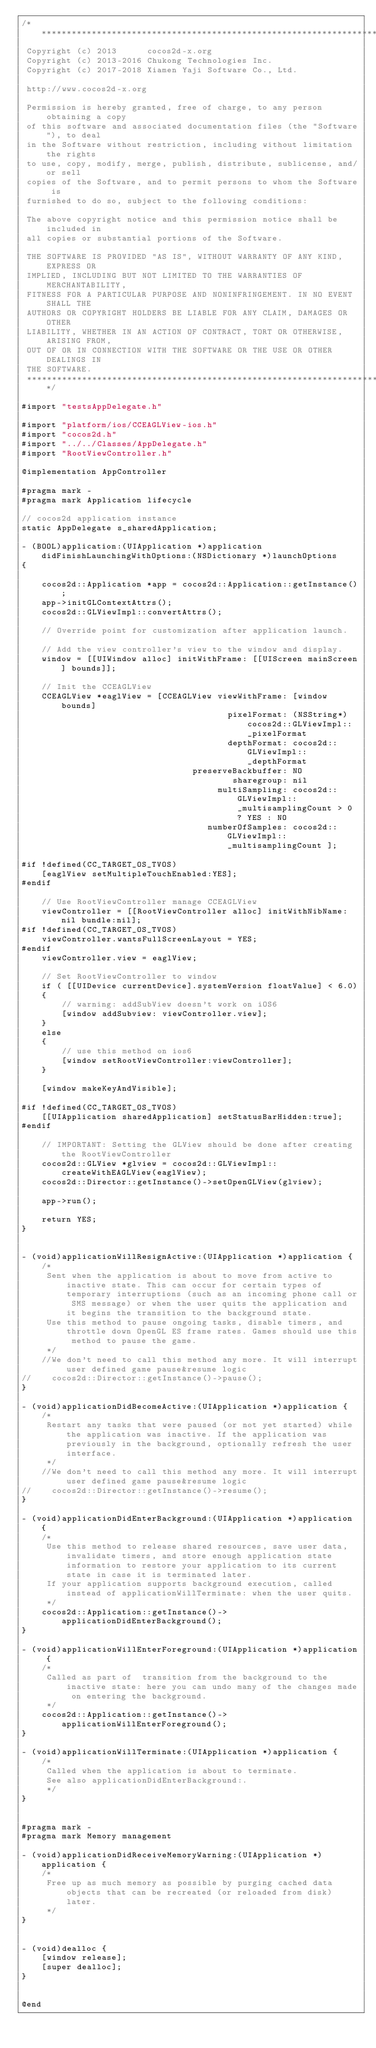Convert code to text. <code><loc_0><loc_0><loc_500><loc_500><_ObjectiveC_>/****************************************************************************
 Copyright (c) 2013      cocos2d-x.org
 Copyright (c) 2013-2016 Chukong Technologies Inc.
 Copyright (c) 2017-2018 Xiamen Yaji Software Co., Ltd.

 http://www.cocos2d-x.org

 Permission is hereby granted, free of charge, to any person obtaining a copy
 of this software and associated documentation files (the "Software"), to deal
 in the Software without restriction, including without limitation the rights
 to use, copy, modify, merge, publish, distribute, sublicense, and/or sell
 copies of the Software, and to permit persons to whom the Software is
 furnished to do so, subject to the following conditions:

 The above copyright notice and this permission notice shall be included in
 all copies or substantial portions of the Software.

 THE SOFTWARE IS PROVIDED "AS IS", WITHOUT WARRANTY OF ANY KIND, EXPRESS OR
 IMPLIED, INCLUDING BUT NOT LIMITED TO THE WARRANTIES OF MERCHANTABILITY,
 FITNESS FOR A PARTICULAR PURPOSE AND NONINFRINGEMENT. IN NO EVENT SHALL THE
 AUTHORS OR COPYRIGHT HOLDERS BE LIABLE FOR ANY CLAIM, DAMAGES OR OTHER
 LIABILITY, WHETHER IN AN ACTION OF CONTRACT, TORT OR OTHERWISE, ARISING FROM,
 OUT OF OR IN CONNECTION WITH THE SOFTWARE OR THE USE OR OTHER DEALINGS IN
 THE SOFTWARE.
 ****************************************************************************/

#import "testsAppDelegate.h"

#import "platform/ios/CCEAGLView-ios.h"
#import "cocos2d.h"
#import "../../Classes/AppDelegate.h"
#import "RootViewController.h"

@implementation AppController

#pragma mark -
#pragma mark Application lifecycle

// cocos2d application instance
static AppDelegate s_sharedApplication;

- (BOOL)application:(UIApplication *)application didFinishLaunchingWithOptions:(NSDictionary *)launchOptions
{

    cocos2d::Application *app = cocos2d::Application::getInstance();
    app->initGLContextAttrs();
    cocos2d::GLViewImpl::convertAttrs();

    // Override point for customization after application launch.

    // Add the view controller's view to the window and display.
    window = [[UIWindow alloc] initWithFrame: [[UIScreen mainScreen] bounds]];

    // Init the CCEAGLView
    CCEAGLView *eaglView = [CCEAGLView viewWithFrame: [window bounds]
                                         pixelFormat: (NSString*)cocos2d::GLViewImpl::_pixelFormat
                                         depthFormat: cocos2d::GLViewImpl::_depthFormat
                                  preserveBackbuffer: NO
                                          sharegroup: nil
                                       multiSampling: cocos2d::GLViewImpl::_multisamplingCount > 0 ? YES : NO
                                     numberOfSamples: cocos2d::GLViewImpl::_multisamplingCount ];

#if !defined(CC_TARGET_OS_TVOS)
    [eaglView setMultipleTouchEnabled:YES];
#endif

    // Use RootViewController manage CCEAGLView
    viewController = [[RootViewController alloc] initWithNibName:nil bundle:nil];
#if !defined(CC_TARGET_OS_TVOS)
    viewController.wantsFullScreenLayout = YES;
#endif
    viewController.view = eaglView;

    // Set RootViewController to window
    if ( [[UIDevice currentDevice].systemVersion floatValue] < 6.0)
    {
        // warning: addSubView doesn't work on iOS6
        [window addSubview: viewController.view];
    }
    else
    {
        // use this method on ios6
        [window setRootViewController:viewController];
    }
    
    [window makeKeyAndVisible];

#if !defined(CC_TARGET_OS_TVOS)
    [[UIApplication sharedApplication] setStatusBarHidden:true];
#endif
    
    // IMPORTANT: Setting the GLView should be done after creating the RootViewController
    cocos2d::GLView *glview = cocos2d::GLViewImpl::createWithEAGLView(eaglView);
    cocos2d::Director::getInstance()->setOpenGLView(glview);

    app->run();

    return YES;
}


- (void)applicationWillResignActive:(UIApplication *)application {
    /*
     Sent when the application is about to move from active to inactive state. This can occur for certain types of temporary interruptions (such as an incoming phone call or SMS message) or when the user quits the application and it begins the transition to the background state.
     Use this method to pause ongoing tasks, disable timers, and throttle down OpenGL ES frame rates. Games should use this method to pause the game.
     */
    //We don't need to call this method any more. It will interrupt user defined game pause&resume logic
//    cocos2d::Director::getInstance()->pause();
}

- (void)applicationDidBecomeActive:(UIApplication *)application {
    /*
     Restart any tasks that were paused (or not yet started) while the application was inactive. If the application was previously in the background, optionally refresh the user interface.
     */
    //We don't need to call this method any more. It will interrupt user defined game pause&resume logic
//    cocos2d::Director::getInstance()->resume();
}

- (void)applicationDidEnterBackground:(UIApplication *)application {
    /*
     Use this method to release shared resources, save user data, invalidate timers, and store enough application state information to restore your application to its current state in case it is terminated later. 
     If your application supports background execution, called instead of applicationWillTerminate: when the user quits.
     */
    cocos2d::Application::getInstance()->applicationDidEnterBackground();
}

- (void)applicationWillEnterForeground:(UIApplication *)application {
    /*
     Called as part of  transition from the background to the inactive state: here you can undo many of the changes made on entering the background.
     */
    cocos2d::Application::getInstance()->applicationWillEnterForeground();
}

- (void)applicationWillTerminate:(UIApplication *)application {
    /*
     Called when the application is about to terminate.
     See also applicationDidEnterBackground:.
     */
}


#pragma mark -
#pragma mark Memory management

- (void)applicationDidReceiveMemoryWarning:(UIApplication *)application {
    /*
     Free up as much memory as possible by purging cached data objects that can be recreated (or reloaded from disk) later.
     */
}


- (void)dealloc {
    [window release];
    [super dealloc];
}


@end
</code> 